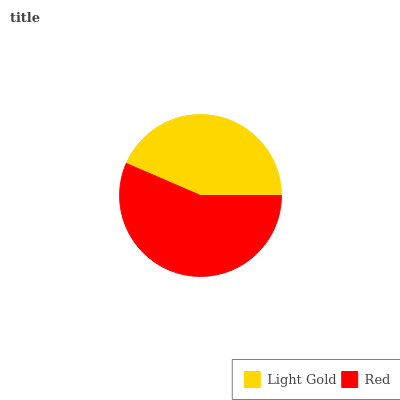Is Light Gold the minimum?
Answer yes or no. Yes. Is Red the maximum?
Answer yes or no. Yes. Is Red the minimum?
Answer yes or no. No. Is Red greater than Light Gold?
Answer yes or no. Yes. Is Light Gold less than Red?
Answer yes or no. Yes. Is Light Gold greater than Red?
Answer yes or no. No. Is Red less than Light Gold?
Answer yes or no. No. Is Red the high median?
Answer yes or no. Yes. Is Light Gold the low median?
Answer yes or no. Yes. Is Light Gold the high median?
Answer yes or no. No. Is Red the low median?
Answer yes or no. No. 